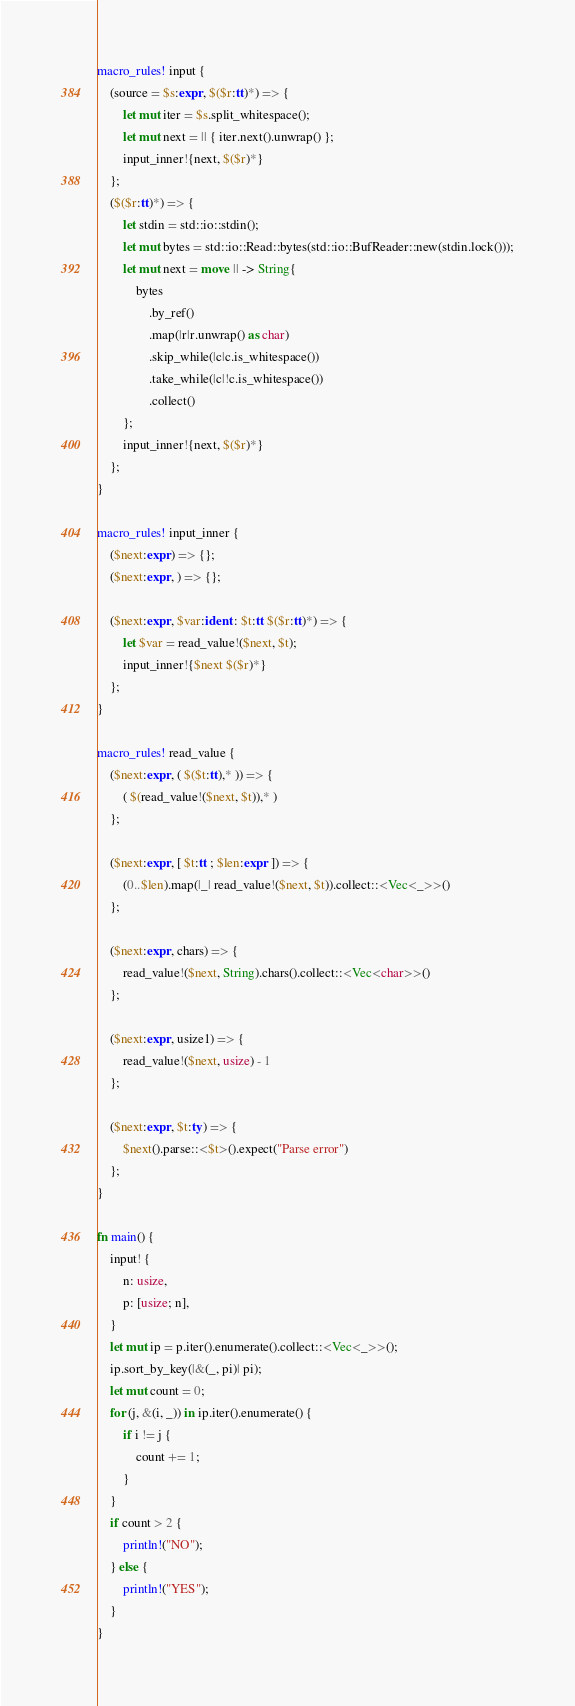<code> <loc_0><loc_0><loc_500><loc_500><_Rust_>macro_rules! input {
    (source = $s:expr, $($r:tt)*) => {
        let mut iter = $s.split_whitespace();
        let mut next = || { iter.next().unwrap() };
        input_inner!{next, $($r)*}
    };
    ($($r:tt)*) => {
        let stdin = std::io::stdin();
        let mut bytes = std::io::Read::bytes(std::io::BufReader::new(stdin.lock()));
        let mut next = move || -> String{
            bytes
                .by_ref()
                .map(|r|r.unwrap() as char)
                .skip_while(|c|c.is_whitespace())
                .take_while(|c|!c.is_whitespace())
                .collect()
        };
        input_inner!{next, $($r)*}
    };
}

macro_rules! input_inner {
    ($next:expr) => {};
    ($next:expr, ) => {};

    ($next:expr, $var:ident : $t:tt $($r:tt)*) => {
        let $var = read_value!($next, $t);
        input_inner!{$next $($r)*}
    };
}

macro_rules! read_value {
    ($next:expr, ( $($t:tt),* )) => {
        ( $(read_value!($next, $t)),* )
    };

    ($next:expr, [ $t:tt ; $len:expr ]) => {
        (0..$len).map(|_| read_value!($next, $t)).collect::<Vec<_>>()
    };

    ($next:expr, chars) => {
        read_value!($next, String).chars().collect::<Vec<char>>()
    };

    ($next:expr, usize1) => {
        read_value!($next, usize) - 1
    };

    ($next:expr, $t:ty) => {
        $next().parse::<$t>().expect("Parse error")
    };
}

fn main() {
    input! {
        n: usize,
        p: [usize; n],
    }
    let mut ip = p.iter().enumerate().collect::<Vec<_>>();
    ip.sort_by_key(|&(_, pi)| pi);
    let mut count = 0;
    for (j, &(i, _)) in ip.iter().enumerate() {
        if i != j {
            count += 1;
        }
    }
    if count > 2 {
        println!("NO");
    } else {
        println!("YES");
    }
}
</code> 